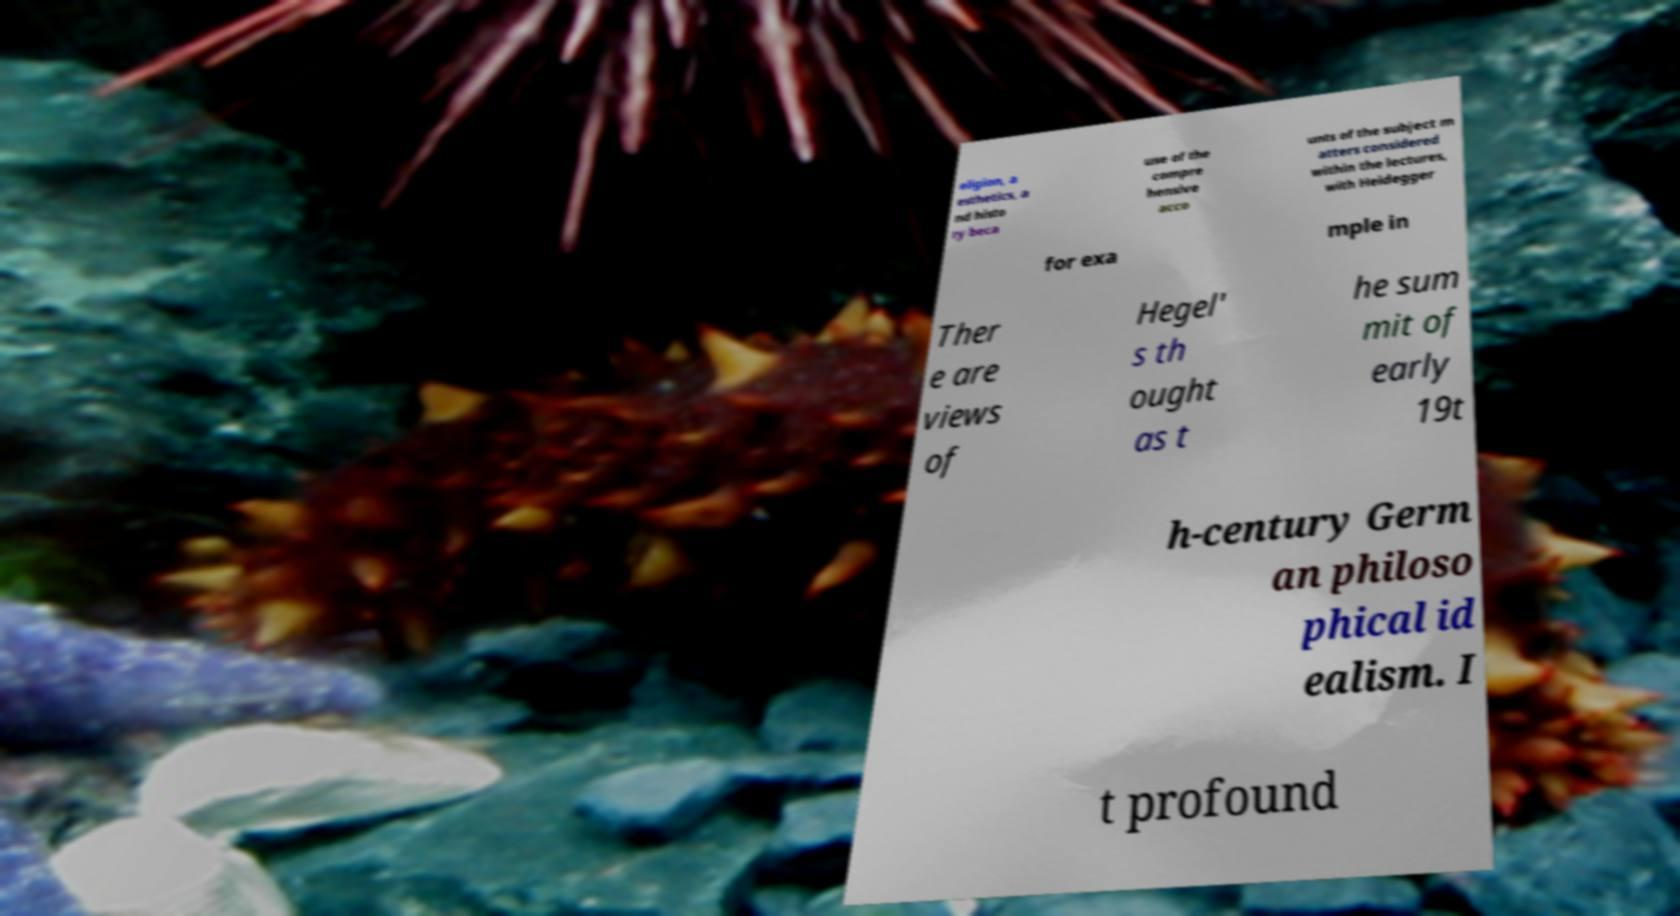Can you accurately transcribe the text from the provided image for me? eligion, a esthetics, a nd histo ry beca use of the compre hensive acco unts of the subject m atters considered within the lectures, with Heidegger for exa mple in Ther e are views of Hegel' s th ought as t he sum mit of early 19t h-century Germ an philoso phical id ealism. I t profound 